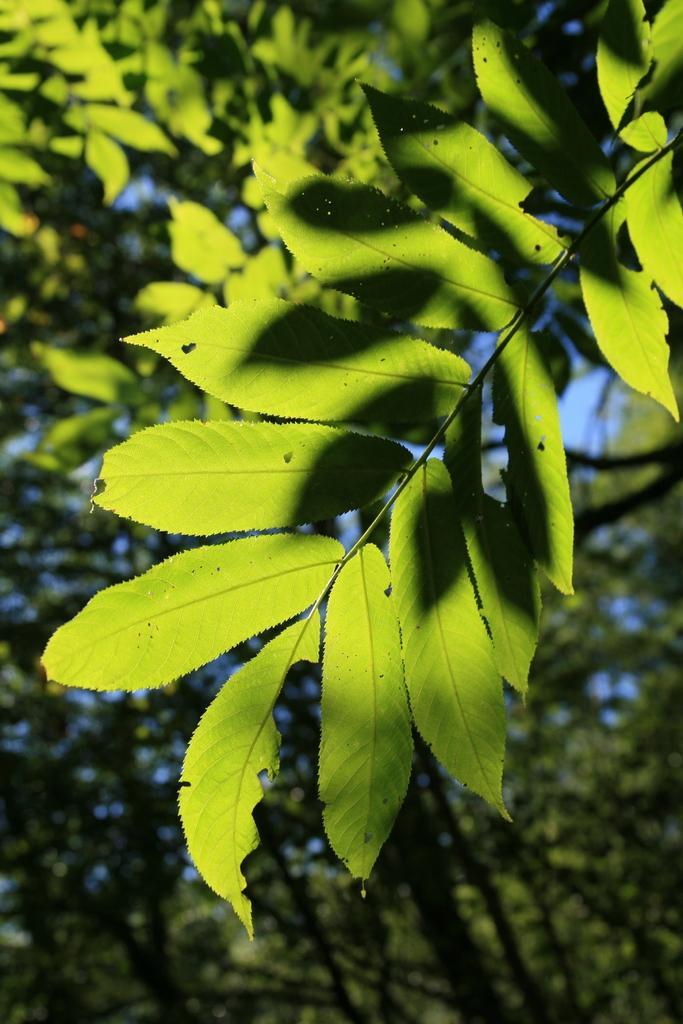Can you describe this image briefly? In the image we can see some trees. 